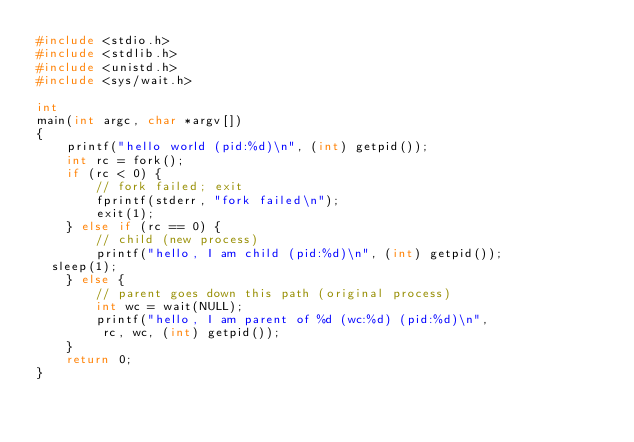<code> <loc_0><loc_0><loc_500><loc_500><_C_>#include <stdio.h>
#include <stdlib.h>
#include <unistd.h>
#include <sys/wait.h>

int
main(int argc, char *argv[])
{
    printf("hello world (pid:%d)\n", (int) getpid());
    int rc = fork();
    if (rc < 0) {
        // fork failed; exit
        fprintf(stderr, "fork failed\n");
        exit(1);
    } else if (rc == 0) {
        // child (new process)
        printf("hello, I am child (pid:%d)\n", (int) getpid());
	sleep(1);
    } else {
        // parent goes down this path (original process)
        int wc = wait(NULL);
        printf("hello, I am parent of %d (wc:%d) (pid:%d)\n",
	       rc, wc, (int) getpid());
    }
    return 0;
}
</code> 